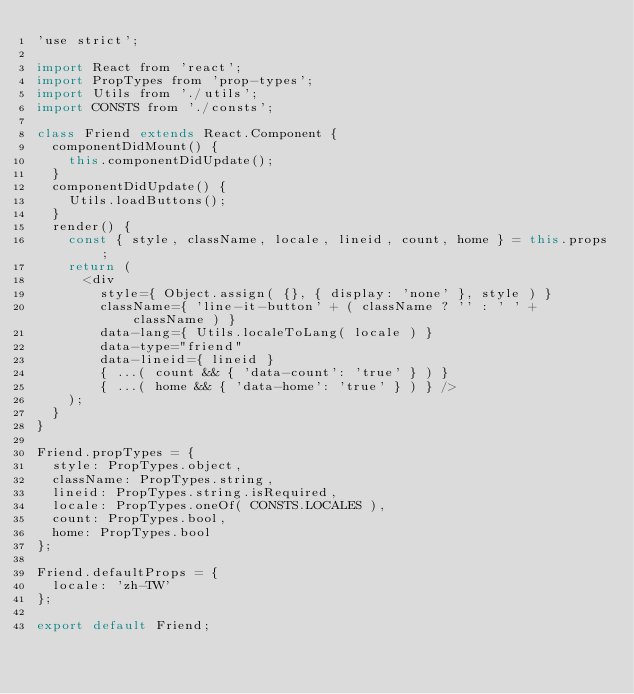<code> <loc_0><loc_0><loc_500><loc_500><_JavaScript_>'use strict';

import React from 'react';
import PropTypes from 'prop-types';
import Utils from './utils';
import CONSTS from './consts';

class Friend extends React.Component {
  componentDidMount() {
    this.componentDidUpdate();
  }
  componentDidUpdate() {
    Utils.loadButtons();
  }
  render() {
    const { style, className, locale, lineid, count, home } = this.props;
    return (
      <div
        style={ Object.assign( {}, { display: 'none' }, style ) }
        className={ 'line-it-button' + ( className ? '' : ' ' + className ) }
        data-lang={ Utils.localeToLang( locale ) }
        data-type="friend"
        data-lineid={ lineid }
        { ...( count && { 'data-count': 'true' } ) }
        { ...( home && { 'data-home': 'true' } ) } />
    );
  }
}

Friend.propTypes = {
  style: PropTypes.object,
  className: PropTypes.string,
  lineid: PropTypes.string.isRequired,
  locale: PropTypes.oneOf( CONSTS.LOCALES ),
  count: PropTypes.bool,
  home: PropTypes.bool
};

Friend.defaultProps = {
  locale: 'zh-TW'
};

export default Friend;
</code> 